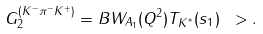<formula> <loc_0><loc_0><loc_500><loc_500>G _ { 2 } ^ { ( K ^ { - } \pi ^ { - } K ^ { + } ) } = B W _ { A _ { 1 } } ( Q ^ { 2 } ) T _ { K ^ { ^ { * } } } ( s _ { 1 } ) \ > .</formula> 